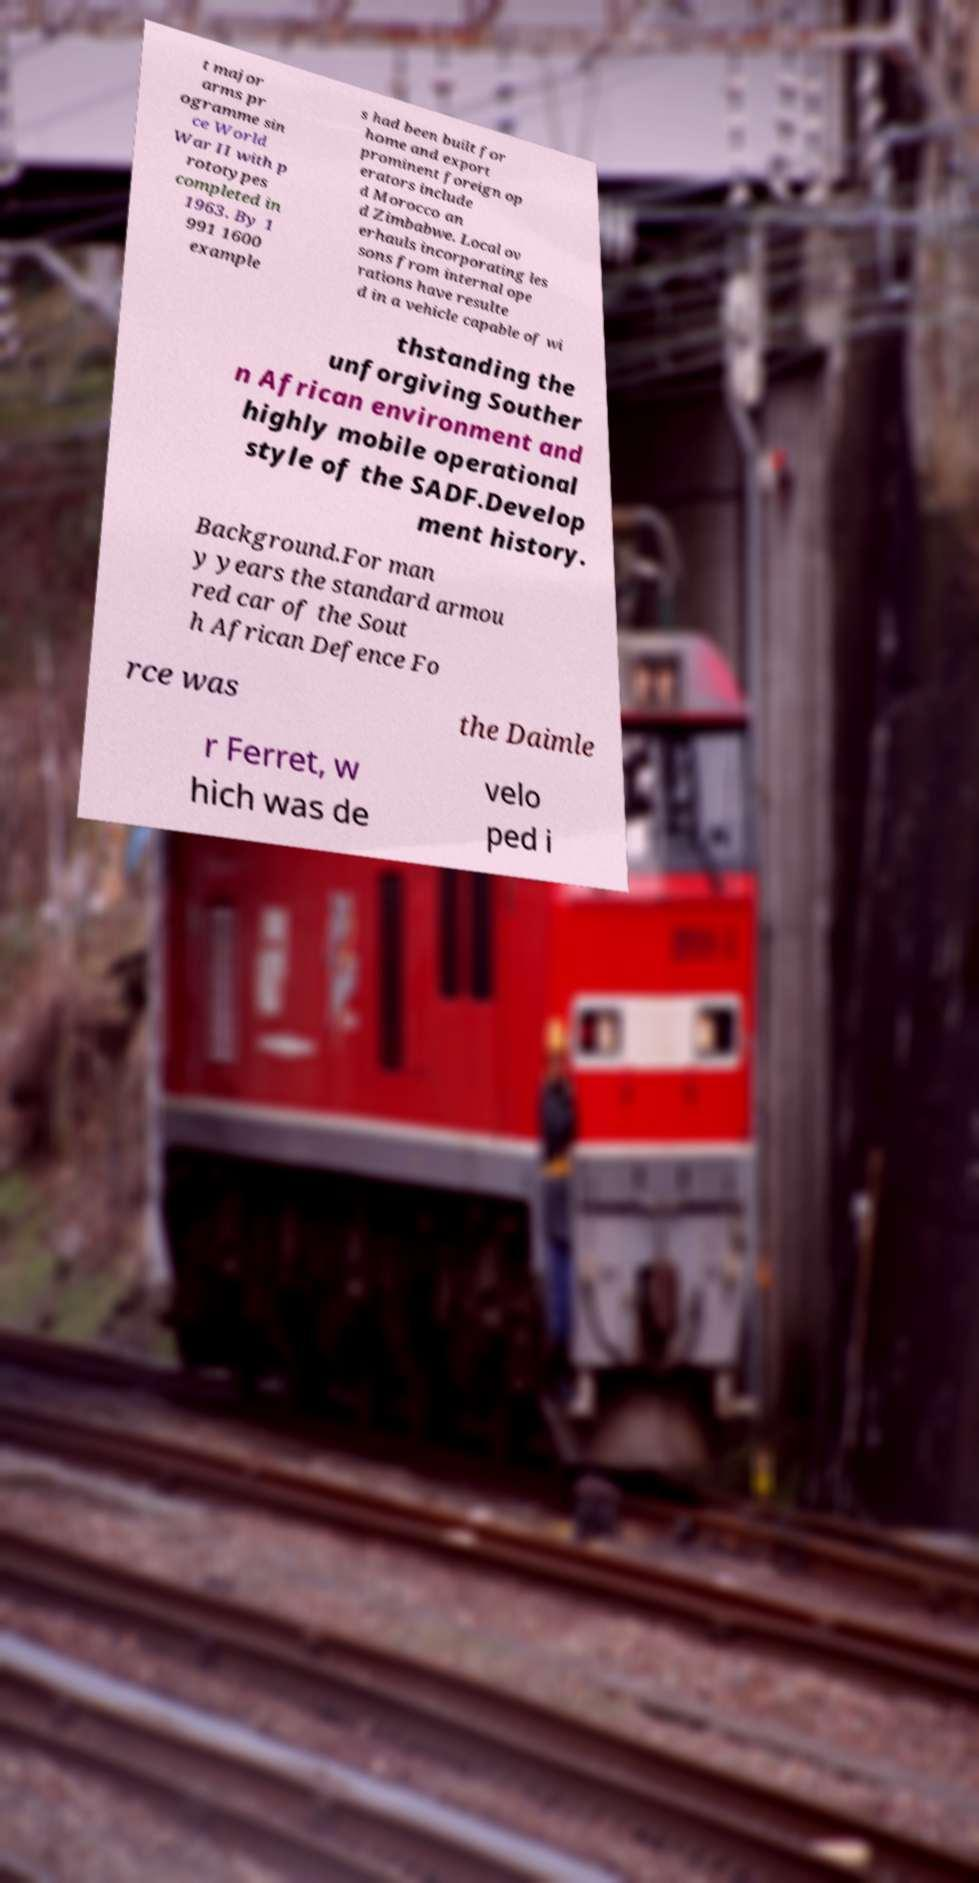Could you assist in decoding the text presented in this image and type it out clearly? t major arms pr ogramme sin ce World War II with p rototypes completed in 1963. By 1 991 1600 example s had been built for home and export prominent foreign op erators include d Morocco an d Zimbabwe. Local ov erhauls incorporating les sons from internal ope rations have resulte d in a vehicle capable of wi thstanding the unforgiving Souther n African environment and highly mobile operational style of the SADF.Develop ment history. Background.For man y years the standard armou red car of the Sout h African Defence Fo rce was the Daimle r Ferret, w hich was de velo ped i 